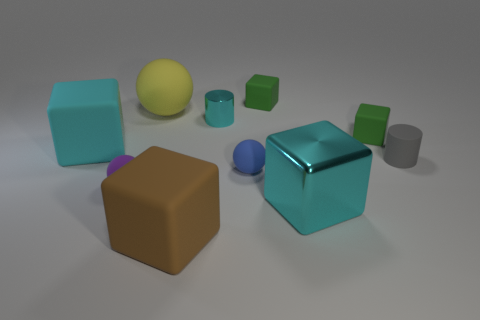There is a metal object that is the same color as the shiny cube; what is its size?
Your answer should be very brief. Small. Is the number of tiny things that are behind the small gray matte cylinder the same as the number of large cyan shiny cubes that are left of the big metal thing?
Offer a terse response. No. Do the cyan metallic cube and the matte cube that is in front of the large cyan rubber thing have the same size?
Offer a very short reply. Yes. Are there more tiny cylinders that are behind the gray rubber cylinder than tiny gray balls?
Offer a very short reply. Yes. How many purple spheres are the same size as the blue sphere?
Provide a succinct answer. 1. Is the size of the sphere to the left of the big sphere the same as the cyan object that is in front of the tiny blue matte object?
Ensure brevity in your answer.  No. Are there more balls that are on the right side of the big cyan matte block than tiny balls to the left of the large cyan metallic cube?
Give a very brief answer. Yes. How many other metallic things are the same shape as the yellow object?
Your response must be concise. 0. What material is the cyan cylinder that is the same size as the blue sphere?
Offer a very short reply. Metal. Are there any cyan cylinders made of the same material as the big brown object?
Ensure brevity in your answer.  No. 